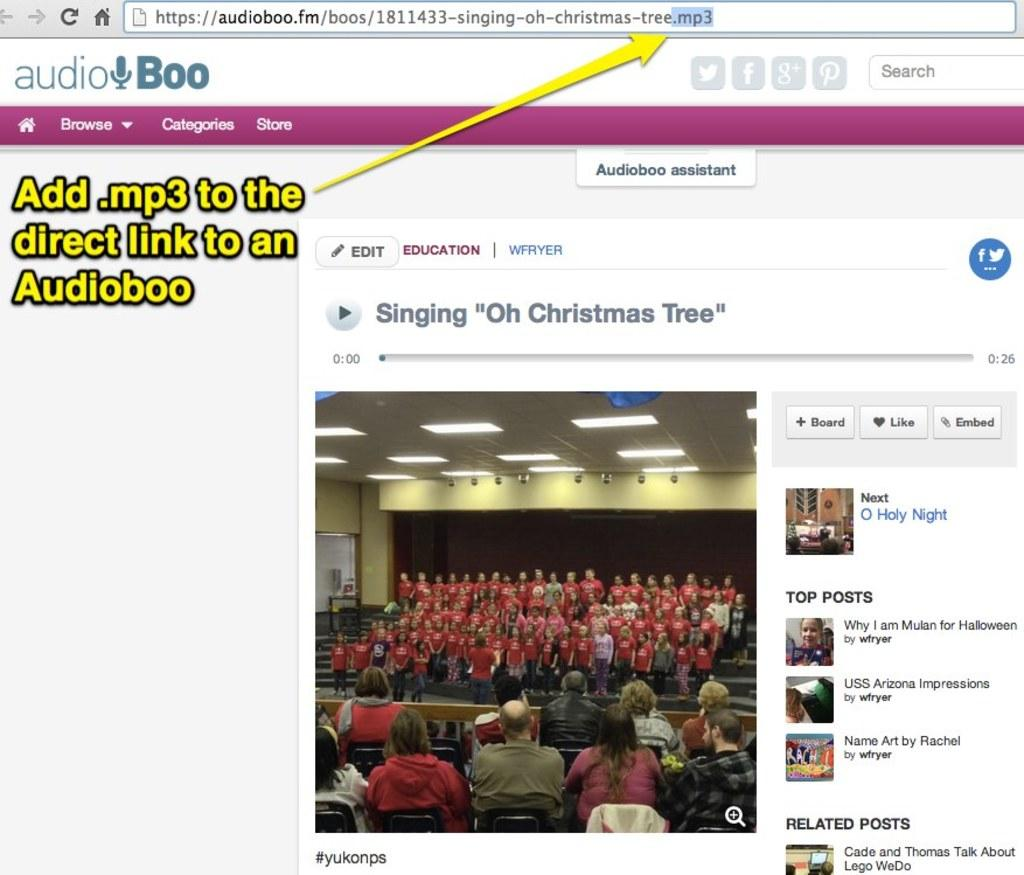What type of image is displayed in the screenshot? The image contains a screenshot of a browser web page. How many clams are visible on the web page in the image? There are no clams visible on the web page in the image. Is there any evidence of spying activity on the web page in the image? There is no indication of spying activity on the web page in the image. 